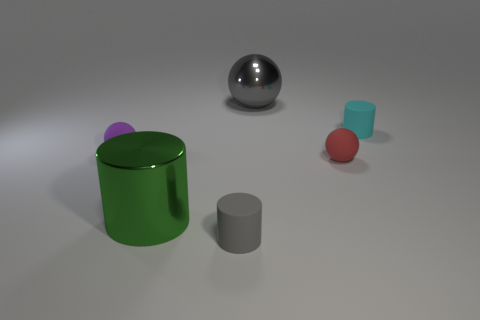Is there a small red object that is in front of the big metal thing that is left of the gray sphere?
Your answer should be compact. No. There is a rubber object that is behind the tiny matte ball on the left side of the small cylinder in front of the tiny red rubber ball; what size is it?
Keep it short and to the point. Small. What material is the large thing in front of the big metal thing that is behind the tiny cyan rubber cylinder?
Provide a succinct answer. Metal. Is there a small purple object that has the same shape as the small cyan rubber thing?
Provide a short and direct response. No. What is the shape of the cyan rubber object?
Provide a succinct answer. Cylinder. What material is the small purple thing on the left side of the large metallic object that is behind the small cyan matte object that is behind the tiny red thing?
Provide a short and direct response. Rubber. Are there more small matte cylinders that are behind the large gray metal thing than big cyan cylinders?
Your answer should be compact. No. What material is the ball that is the same size as the green cylinder?
Keep it short and to the point. Metal. Are there any red balls of the same size as the cyan matte cylinder?
Your response must be concise. Yes. There is a metal thing behind the cyan matte cylinder; what size is it?
Your response must be concise. Large. 